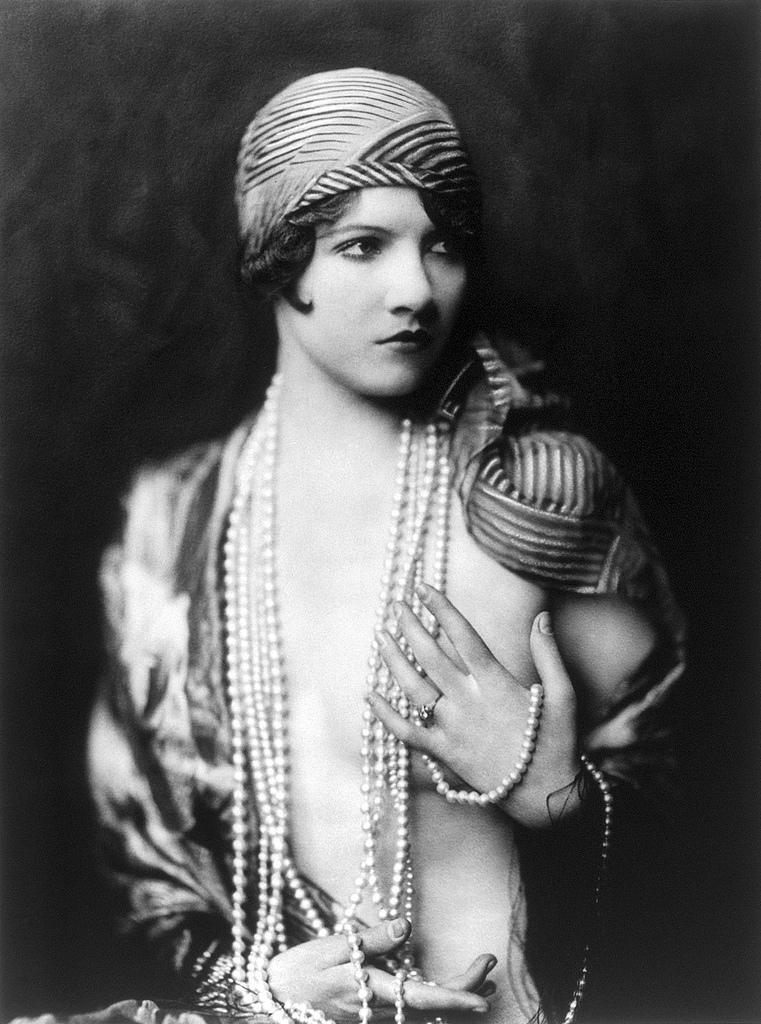What is the color scheme of the image? The image is black and white. Can you describe the main subject of the image? There is a person in the image. What is the person wearing in the image? The person is wearing pearl jewelry. What is the person doing in the image? The person is giving a pose. What type of hat is the person wearing in the image? There is no hat visible in the image; the person is wearing pearl jewelry. How many fingers can be seen on the person's left hand in the image? The image is black and white, and it is not possible to determine the number of fingers on the person's hand from the available information. 